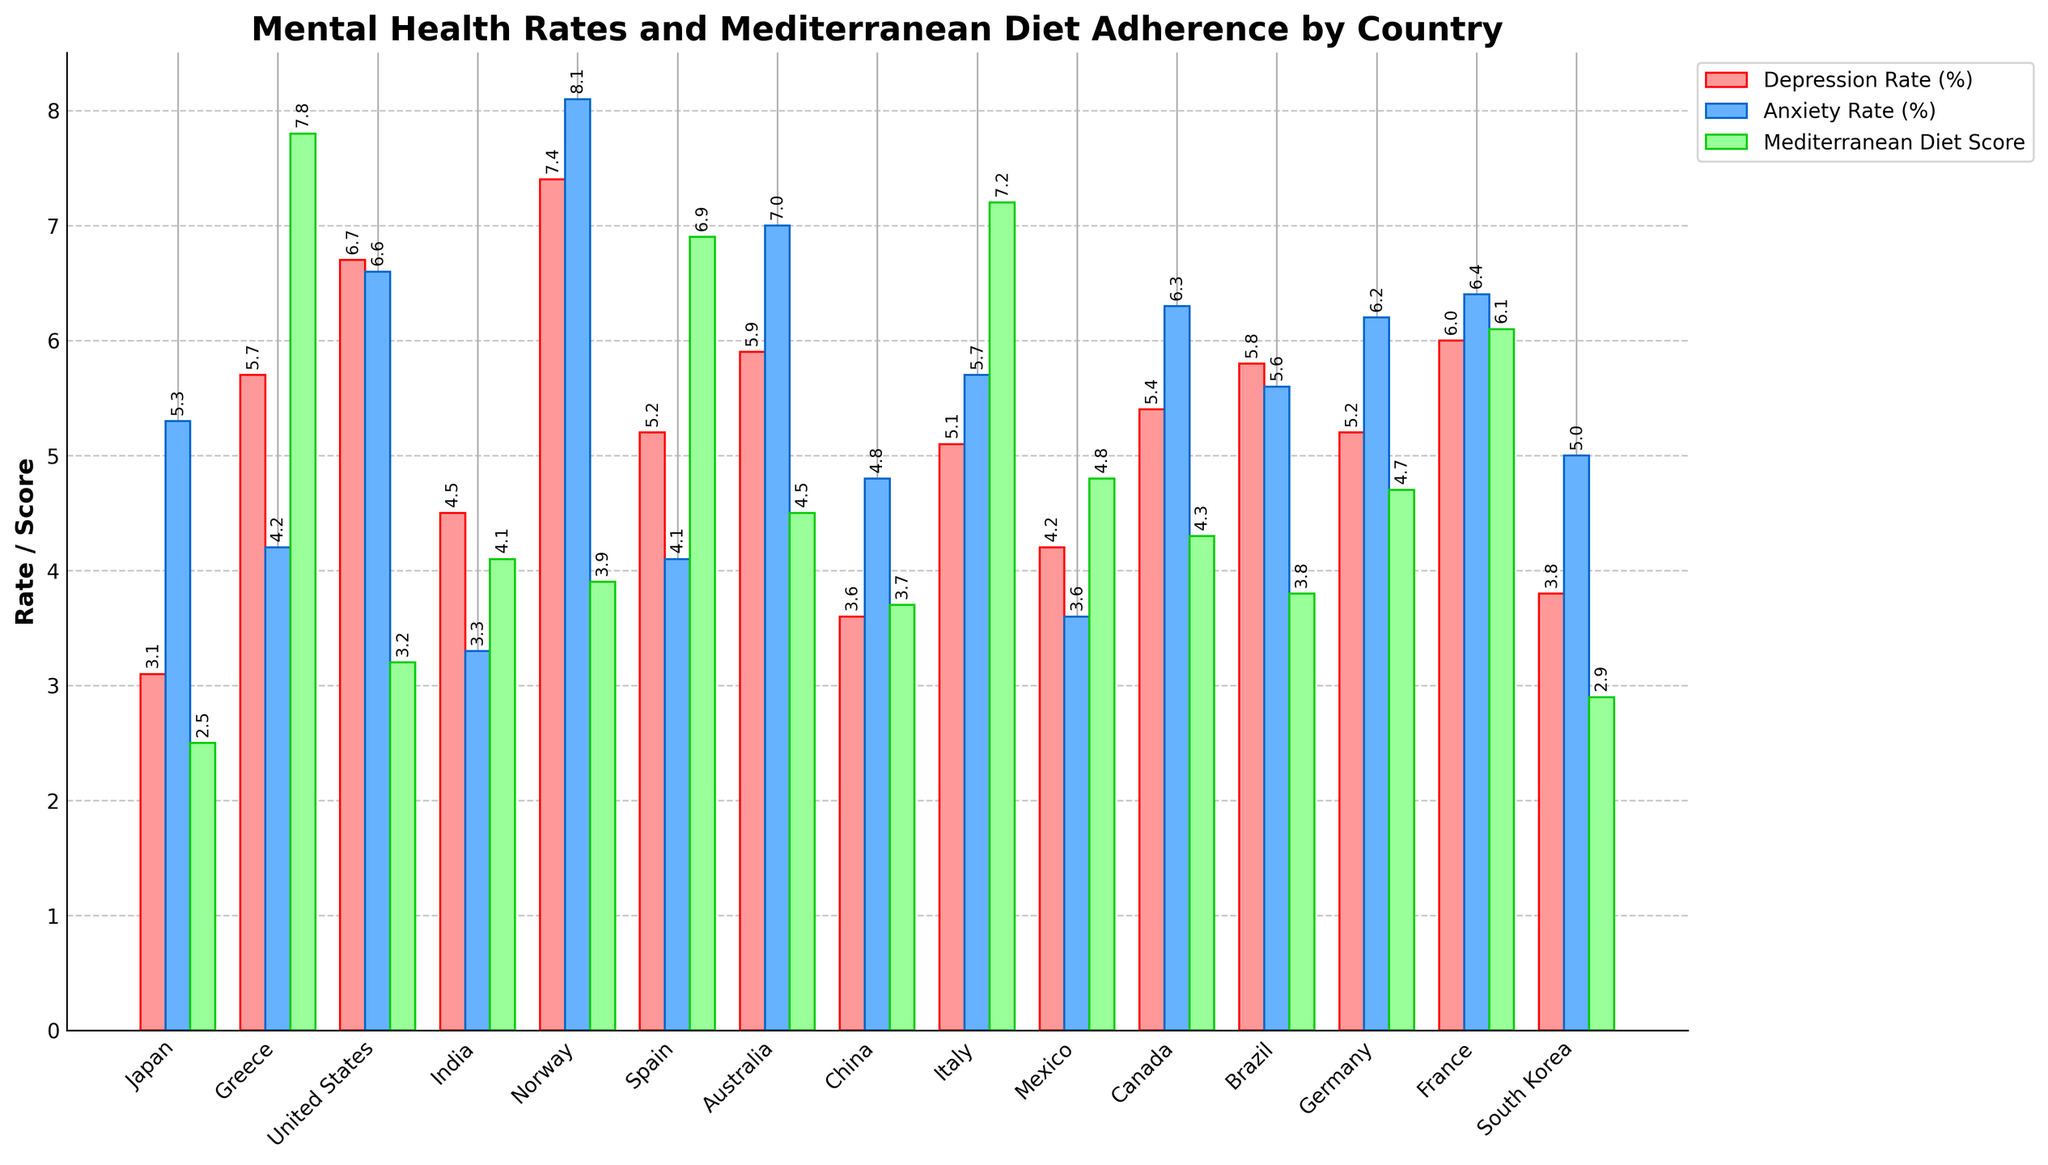Which country has the highest depression rate? By visually checking the height of the red bars representing the depression rate, Norway has the highest depression rate among the countries presented in the bar chart with a rate of 7.4%.
Answer: Norway Which country exhibits both low anxiety and low depression rates? By examining the blue bars for anxiety and the red bars for depression, India stands out as having one of the lower rates in both categories, with a depression rate of 4.5% and an anxiety rate of 3.3%.
Answer: India Compare the Mediterranean Diet Adherence Scores of Greece and Australia. Which is higher? Visually inspecting the green bars representing the Mediterranean Diet Adherence Scores, Greece appears to have a higher adherence score compared to Australia. Specifically, Greece has a score of 7.8, while Australia has a score of 4.5.
Answer: Greece What is the difference between the depression rates of Japan and the United States? By looking at the red bars representing the depression rates, Japan has a rate of 3.1% and the United States has a rate of 6.7%. The difference is calculated as 6.7% - 3.1% = 3.6%.
Answer: 3.6% Which country has a higher anxiety rate, Canada or Mexico? By examining the blue bars for anxiety, Canada has a higher anxiety rate of 6.3% compared to Mexico, which has an anxiety rate of 3.6%.
Answer: Canada Calculate the average Mediterranean Diet Adherence Score for countries with depression rates below 5%. The countries with depression rates below 5% are Japan (2.5), India (4.1), China (3.7), South Korea (2.9), and Mexico (4.8). Summing up their Mediterranean Diet Adherence Scores: 2.5 + 4.1 + 3.7 + 2.9 + 4.8 = 18.0. The average is thus 18.0 / 5 = 3.6.
Answer: 3.6 Which country has the most balanced rates between anxiety and depression? By comparing the heights of the red and blue bars for each country, Mexico appears to have similar bars for both measures: 4.2% depression rate and 3.6% anxiety rate.
Answer: Mexico What is the combined rate of depression and anxiety in Germany? Summing the depression rate and anxiety rate for Germany, which are 5.2% and 6.2% respectively, gives a combined rate of 5.2 + 6.2 = 11.4%.
Answer: 11.4% Which country shows the least adherence to the Mediterranean Diet and what is their depression rate? Japan has the lowest Mediterranean Diet Adherence Score of 2.5. Their depression rate is 3.1%.
Answer: Japan, 3.1% Are there any countries with anxiety rates over 8%? If so, name them. By examining the blue bars representing anxiety rates, Norway is the only country with an anxiety rate over 8%, specifically at 8.1%.
Answer: Norway 